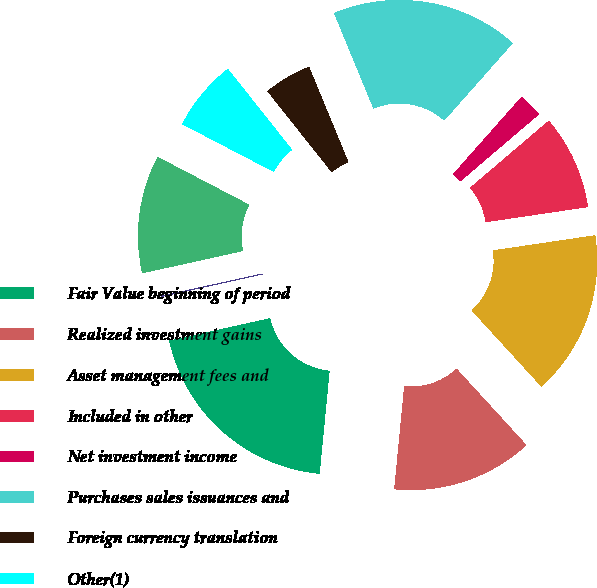Convert chart to OTSL. <chart><loc_0><loc_0><loc_500><loc_500><pie_chart><fcel>Fair Value beginning of period<fcel>Realized investment gains<fcel>Asset management fees and<fcel>Included in other<fcel>Net investment income<fcel>Purchases sales issuances and<fcel>Foreign currency translation<fcel>Other(1)<fcel>Transfers into Level 3(2)<fcel>Transfers out of Level 3(2)<nl><fcel>19.98%<fcel>13.33%<fcel>15.55%<fcel>8.89%<fcel>2.23%<fcel>17.77%<fcel>4.45%<fcel>6.67%<fcel>11.11%<fcel>0.02%<nl></chart> 